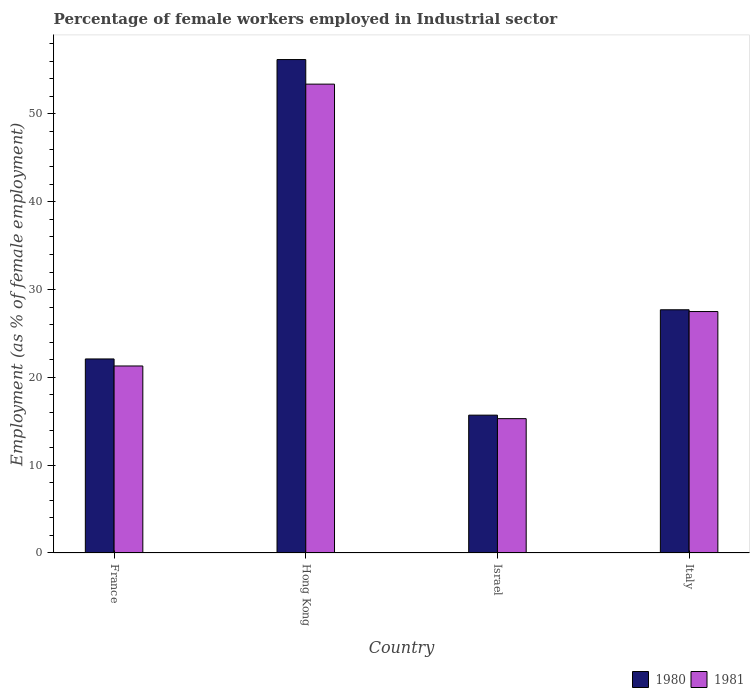How many groups of bars are there?
Provide a succinct answer. 4. Are the number of bars per tick equal to the number of legend labels?
Provide a short and direct response. Yes. What is the label of the 3rd group of bars from the left?
Your response must be concise. Israel. In how many cases, is the number of bars for a given country not equal to the number of legend labels?
Keep it short and to the point. 0. What is the percentage of females employed in Industrial sector in 1980 in France?
Keep it short and to the point. 22.1. Across all countries, what is the maximum percentage of females employed in Industrial sector in 1981?
Offer a very short reply. 53.4. Across all countries, what is the minimum percentage of females employed in Industrial sector in 1981?
Your answer should be compact. 15.3. In which country was the percentage of females employed in Industrial sector in 1980 maximum?
Offer a terse response. Hong Kong. In which country was the percentage of females employed in Industrial sector in 1980 minimum?
Keep it short and to the point. Israel. What is the total percentage of females employed in Industrial sector in 1980 in the graph?
Your answer should be very brief. 121.7. What is the difference between the percentage of females employed in Industrial sector in 1981 in Hong Kong and that in Israel?
Keep it short and to the point. 38.1. What is the difference between the percentage of females employed in Industrial sector in 1980 in France and the percentage of females employed in Industrial sector in 1981 in Hong Kong?
Your answer should be very brief. -31.3. What is the average percentage of females employed in Industrial sector in 1981 per country?
Provide a succinct answer. 29.38. What is the difference between the percentage of females employed in Industrial sector of/in 1981 and percentage of females employed in Industrial sector of/in 1980 in France?
Your response must be concise. -0.8. In how many countries, is the percentage of females employed in Industrial sector in 1981 greater than 16 %?
Offer a terse response. 3. What is the ratio of the percentage of females employed in Industrial sector in 1981 in France to that in Israel?
Make the answer very short. 1.39. What is the difference between the highest and the second highest percentage of females employed in Industrial sector in 1981?
Offer a very short reply. -6.2. What is the difference between the highest and the lowest percentage of females employed in Industrial sector in 1981?
Offer a very short reply. 38.1. In how many countries, is the percentage of females employed in Industrial sector in 1980 greater than the average percentage of females employed in Industrial sector in 1980 taken over all countries?
Keep it short and to the point. 1. What does the 2nd bar from the left in Israel represents?
Your answer should be very brief. 1981. What is the difference between two consecutive major ticks on the Y-axis?
Make the answer very short. 10. Does the graph contain any zero values?
Your response must be concise. No. Does the graph contain grids?
Provide a succinct answer. No. Where does the legend appear in the graph?
Make the answer very short. Bottom right. What is the title of the graph?
Your answer should be compact. Percentage of female workers employed in Industrial sector. Does "1988" appear as one of the legend labels in the graph?
Keep it short and to the point. No. What is the label or title of the X-axis?
Give a very brief answer. Country. What is the label or title of the Y-axis?
Your answer should be compact. Employment (as % of female employment). What is the Employment (as % of female employment) of 1980 in France?
Provide a succinct answer. 22.1. What is the Employment (as % of female employment) in 1981 in France?
Offer a very short reply. 21.3. What is the Employment (as % of female employment) of 1980 in Hong Kong?
Your answer should be compact. 56.2. What is the Employment (as % of female employment) of 1981 in Hong Kong?
Provide a short and direct response. 53.4. What is the Employment (as % of female employment) in 1980 in Israel?
Offer a very short reply. 15.7. What is the Employment (as % of female employment) in 1981 in Israel?
Your answer should be compact. 15.3. What is the Employment (as % of female employment) in 1980 in Italy?
Ensure brevity in your answer.  27.7. Across all countries, what is the maximum Employment (as % of female employment) of 1980?
Provide a succinct answer. 56.2. Across all countries, what is the maximum Employment (as % of female employment) of 1981?
Provide a short and direct response. 53.4. Across all countries, what is the minimum Employment (as % of female employment) of 1980?
Keep it short and to the point. 15.7. Across all countries, what is the minimum Employment (as % of female employment) of 1981?
Provide a short and direct response. 15.3. What is the total Employment (as % of female employment) in 1980 in the graph?
Provide a succinct answer. 121.7. What is the total Employment (as % of female employment) in 1981 in the graph?
Ensure brevity in your answer.  117.5. What is the difference between the Employment (as % of female employment) in 1980 in France and that in Hong Kong?
Your answer should be very brief. -34.1. What is the difference between the Employment (as % of female employment) of 1981 in France and that in Hong Kong?
Offer a terse response. -32.1. What is the difference between the Employment (as % of female employment) in 1980 in France and that in Israel?
Provide a short and direct response. 6.4. What is the difference between the Employment (as % of female employment) in 1980 in Hong Kong and that in Israel?
Offer a very short reply. 40.5. What is the difference between the Employment (as % of female employment) in 1981 in Hong Kong and that in Israel?
Provide a succinct answer. 38.1. What is the difference between the Employment (as % of female employment) of 1981 in Hong Kong and that in Italy?
Provide a succinct answer. 25.9. What is the difference between the Employment (as % of female employment) in 1980 in France and the Employment (as % of female employment) in 1981 in Hong Kong?
Provide a short and direct response. -31.3. What is the difference between the Employment (as % of female employment) in 1980 in Hong Kong and the Employment (as % of female employment) in 1981 in Israel?
Provide a succinct answer. 40.9. What is the difference between the Employment (as % of female employment) of 1980 in Hong Kong and the Employment (as % of female employment) of 1981 in Italy?
Give a very brief answer. 28.7. What is the difference between the Employment (as % of female employment) in 1980 in Israel and the Employment (as % of female employment) in 1981 in Italy?
Offer a very short reply. -11.8. What is the average Employment (as % of female employment) in 1980 per country?
Offer a very short reply. 30.43. What is the average Employment (as % of female employment) of 1981 per country?
Offer a terse response. 29.38. What is the ratio of the Employment (as % of female employment) in 1980 in France to that in Hong Kong?
Make the answer very short. 0.39. What is the ratio of the Employment (as % of female employment) of 1981 in France to that in Hong Kong?
Keep it short and to the point. 0.4. What is the ratio of the Employment (as % of female employment) in 1980 in France to that in Israel?
Your response must be concise. 1.41. What is the ratio of the Employment (as % of female employment) of 1981 in France to that in Israel?
Ensure brevity in your answer.  1.39. What is the ratio of the Employment (as % of female employment) in 1980 in France to that in Italy?
Ensure brevity in your answer.  0.8. What is the ratio of the Employment (as % of female employment) in 1981 in France to that in Italy?
Your response must be concise. 0.77. What is the ratio of the Employment (as % of female employment) in 1980 in Hong Kong to that in Israel?
Provide a succinct answer. 3.58. What is the ratio of the Employment (as % of female employment) in 1981 in Hong Kong to that in Israel?
Provide a succinct answer. 3.49. What is the ratio of the Employment (as % of female employment) of 1980 in Hong Kong to that in Italy?
Your response must be concise. 2.03. What is the ratio of the Employment (as % of female employment) of 1981 in Hong Kong to that in Italy?
Make the answer very short. 1.94. What is the ratio of the Employment (as % of female employment) in 1980 in Israel to that in Italy?
Offer a very short reply. 0.57. What is the ratio of the Employment (as % of female employment) of 1981 in Israel to that in Italy?
Offer a terse response. 0.56. What is the difference between the highest and the second highest Employment (as % of female employment) in 1981?
Keep it short and to the point. 25.9. What is the difference between the highest and the lowest Employment (as % of female employment) of 1980?
Keep it short and to the point. 40.5. What is the difference between the highest and the lowest Employment (as % of female employment) of 1981?
Make the answer very short. 38.1. 